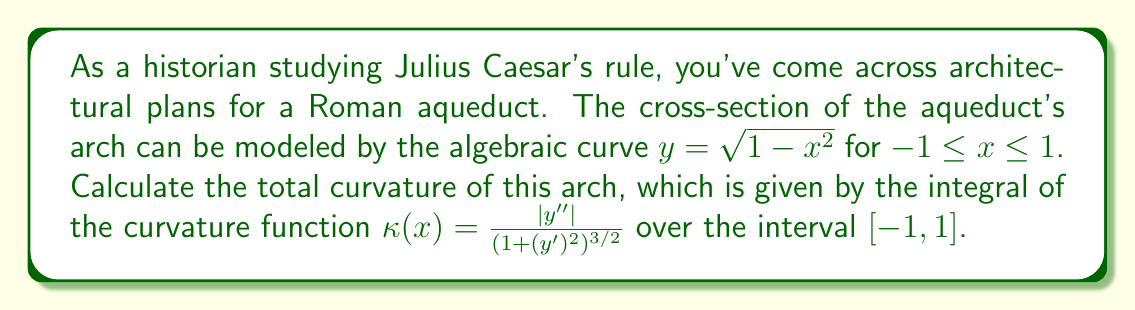Provide a solution to this math problem. Let's approach this step-by-step:

1) First, we need to find $y'$ and $y''$:
   
   $y = \sqrt{1 - x^2}$
   $y' = \frac{-x}{\sqrt{1 - x^2}}$
   $y'' = \frac{-\sqrt{1 - x^2} + x^2 / \sqrt{1 - x^2}}{1 - x^2} = \frac{-1}{(1 - x^2)^{3/2}}$

2) Now, let's substitute these into the curvature function:

   $\kappa(x) = \frac{|-1 / (1 - x^2)^{3/2}|}{(1 + (-x / \sqrt{1 - x^2})^2)^{3/2}}$

3) Simplify the denominator:

   $(1 + (-x / \sqrt{1 - x^2})^2)^{3/2} = (1 + x^2 / (1 - x^2))^{3/2} = (1 / (1 - x^2))^{3/2}$

4) Therefore, the curvature function simplifies to:

   $\kappa(x) = 1$

5) The total curvature is the integral of $\kappa(x)$ from -1 to 1:

   $\int_{-1}^1 \kappa(x) dx = \int_{-1}^1 1 dx = x |_{-1}^1 = 1 - (-1) = 2$

This result, 2, is significant in geometry. It represents the total angle swept out by the normal vector as it traverses the curve, which for a semicircle is indeed $\pi$ radians or 180 degrees.
Answer: 2 